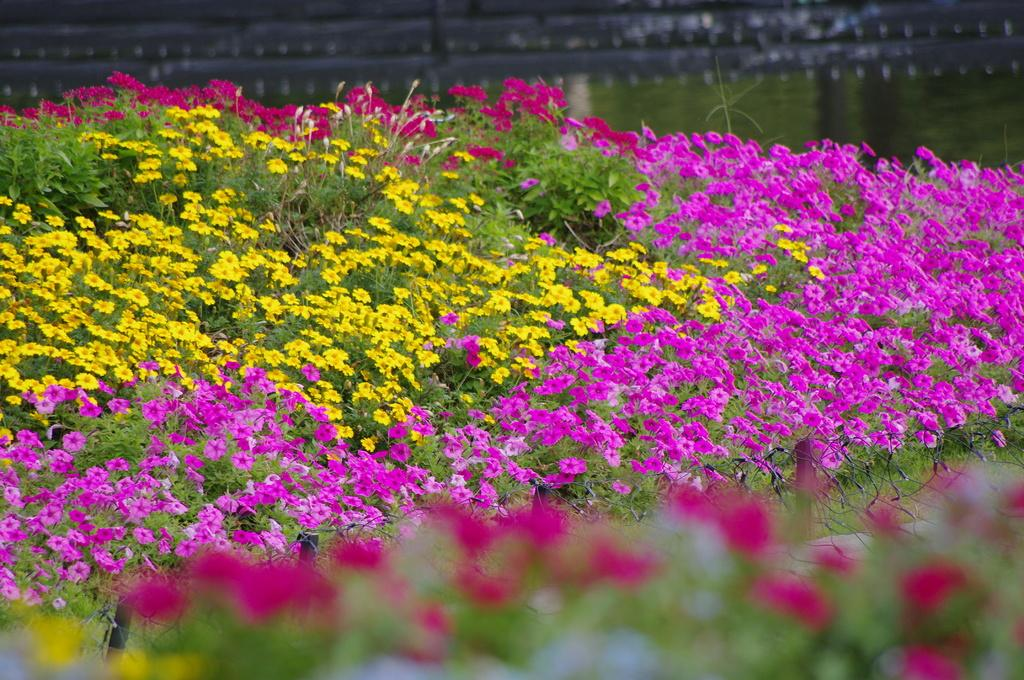What type of plants can be seen in the image? There are plants with flowers in the image. What type of vegetation is visible in the background of the image? There is grass visible in the background of the image. Can you describe any other objects or features in the background of the image? There are some unspecified objects in the background of the image. How many lizards can be seen interacting with the plants in the image? There are no lizards present in the image; it only features plants with flowers and grass in the background. 